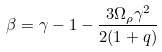Convert formula to latex. <formula><loc_0><loc_0><loc_500><loc_500>\beta = \gamma - 1 - \frac { 3 \Omega _ { \rho } \gamma ^ { 2 } } { 2 ( 1 + q ) }</formula> 